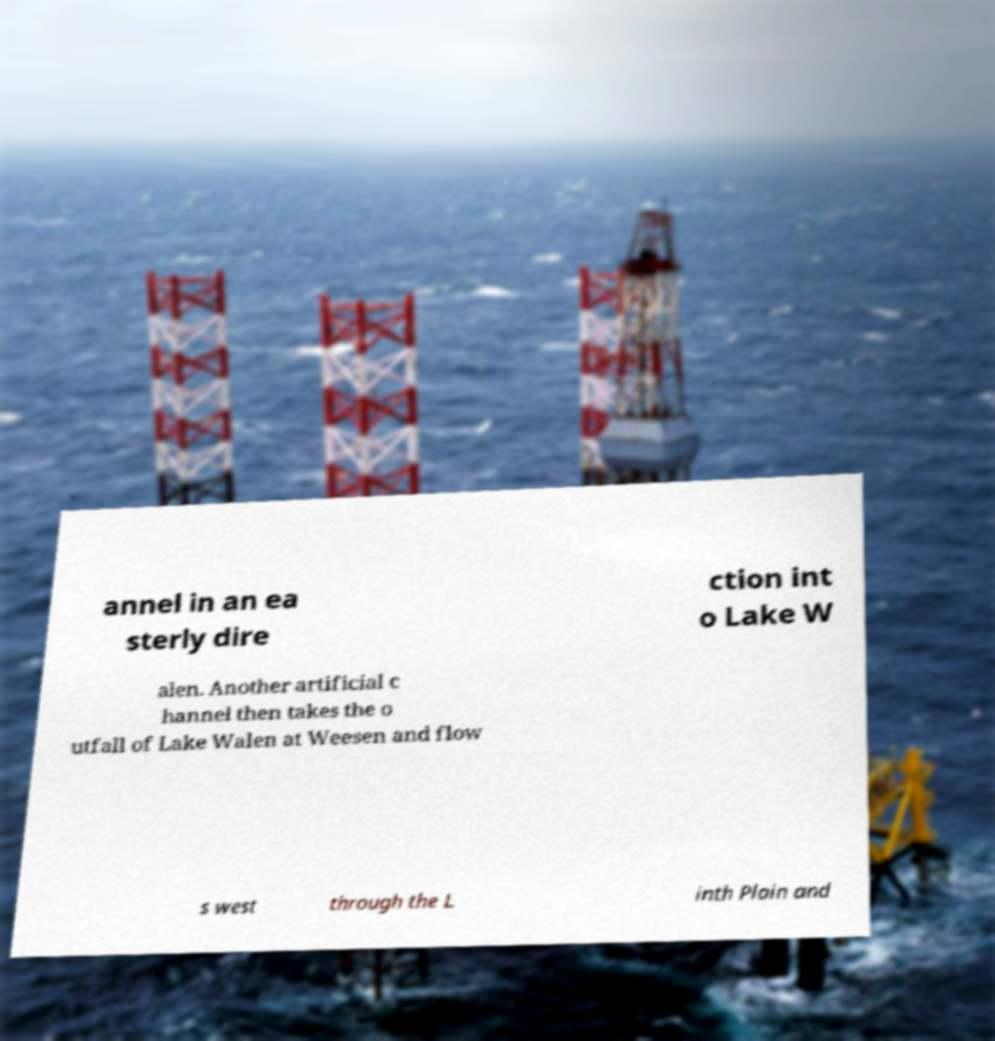Can you read and provide the text displayed in the image?This photo seems to have some interesting text. Can you extract and type it out for me? annel in an ea sterly dire ction int o Lake W alen. Another artificial c hannel then takes the o utfall of Lake Walen at Weesen and flow s west through the L inth Plain and 